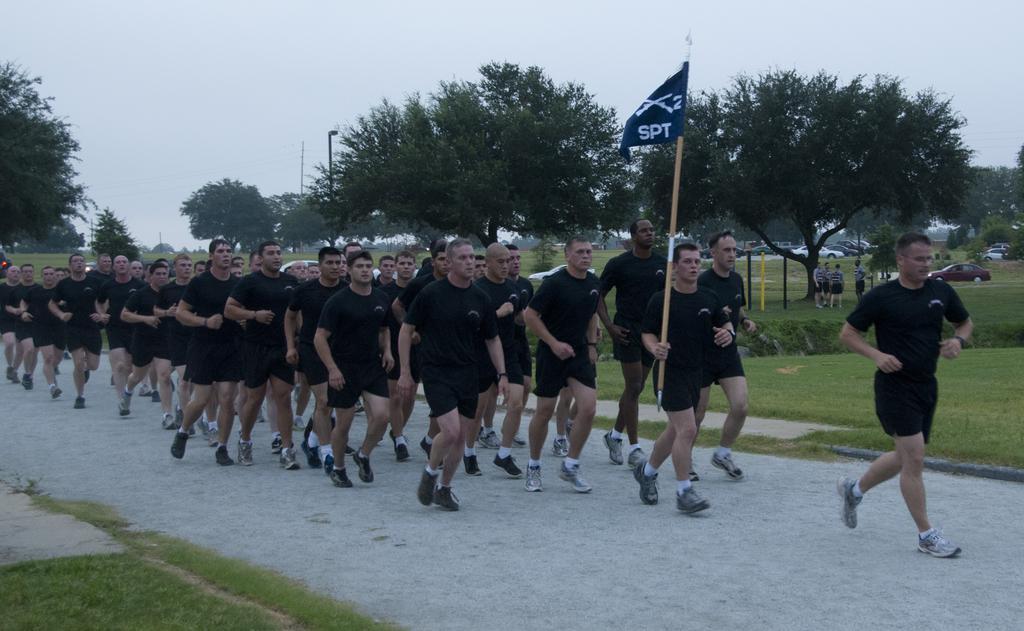Please provide a concise description of this image. In this image we can see group of people are running on the road and there is a person holding a flag with his hand. Here we can see grass, poles, trees, vehicles, and few people. In the background there is sky. 